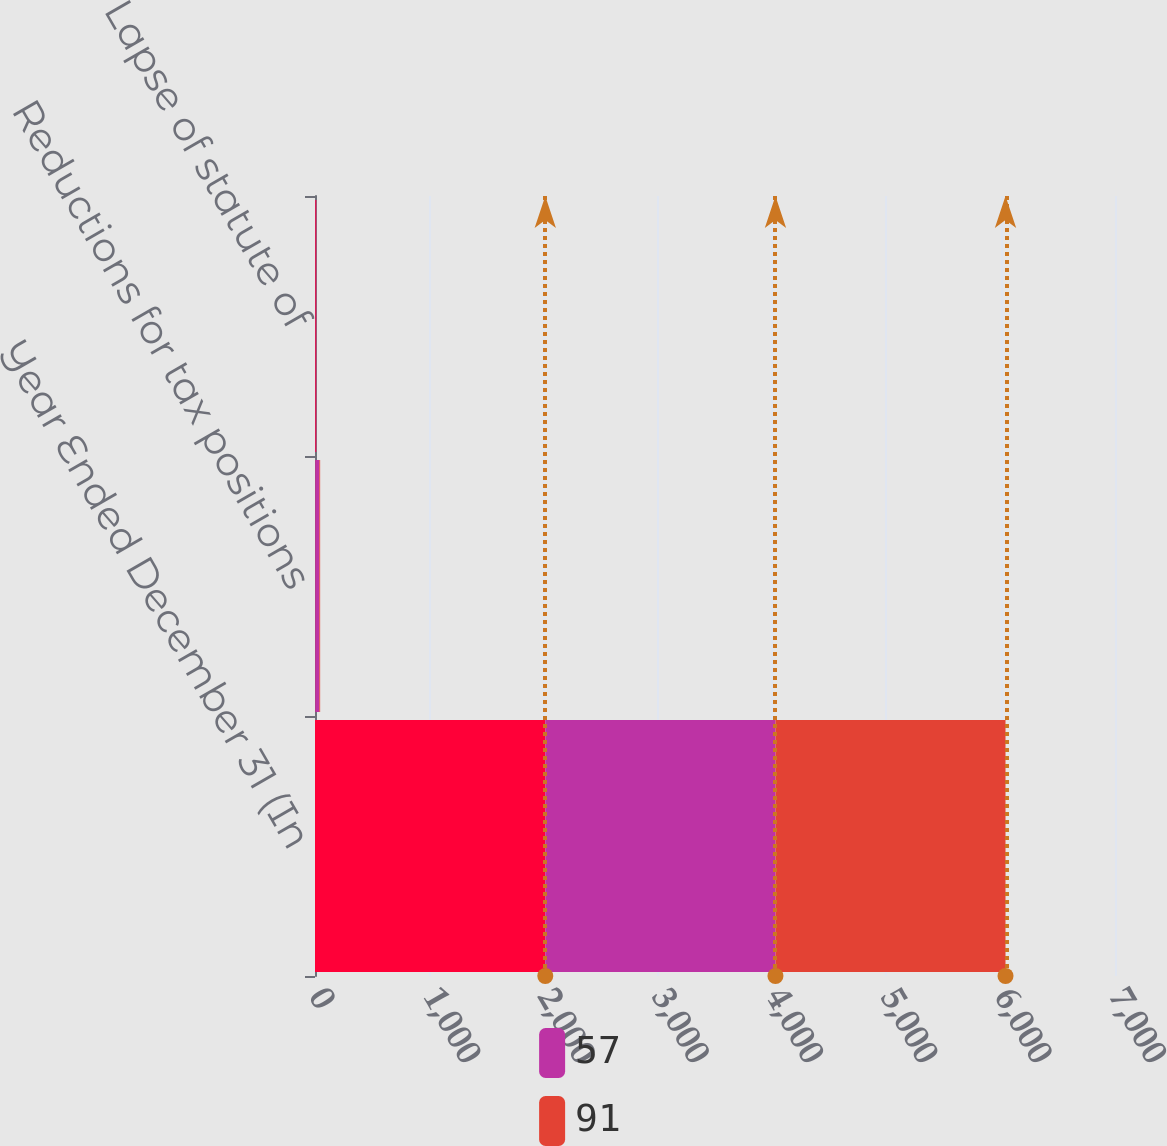Convert chart to OTSL. <chart><loc_0><loc_0><loc_500><loc_500><stacked_bar_chart><ecel><fcel>Year Ended December 31 (In<fcel>Reductions for tax positions<fcel>Lapse of statute of<nl><fcel>nan<fcel>2015<fcel>3<fcel>7<nl><fcel>57<fcel>2014<fcel>35<fcel>5<nl><fcel>91<fcel>2013<fcel>7<fcel>2<nl></chart> 